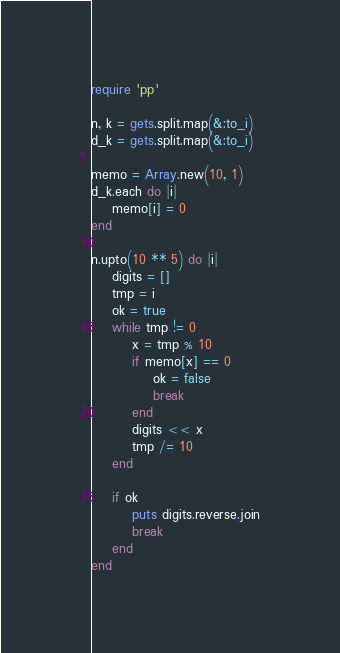Convert code to text. <code><loc_0><loc_0><loc_500><loc_500><_Ruby_>require 'pp'

n, k = gets.split.map(&:to_i)
d_k = gets.split.map(&:to_i)

memo = Array.new(10, 1)
d_k.each do |i|
    memo[i] = 0
end

n.upto(10 ** 5) do |i|
    digits = []
    tmp = i
    ok = true
    while tmp != 0
        x = tmp % 10
        if memo[x] == 0
            ok = false
            break
        end
        digits << x
        tmp /= 10
    end

    if ok
        puts digits.reverse.join
        break
    end
end
</code> 